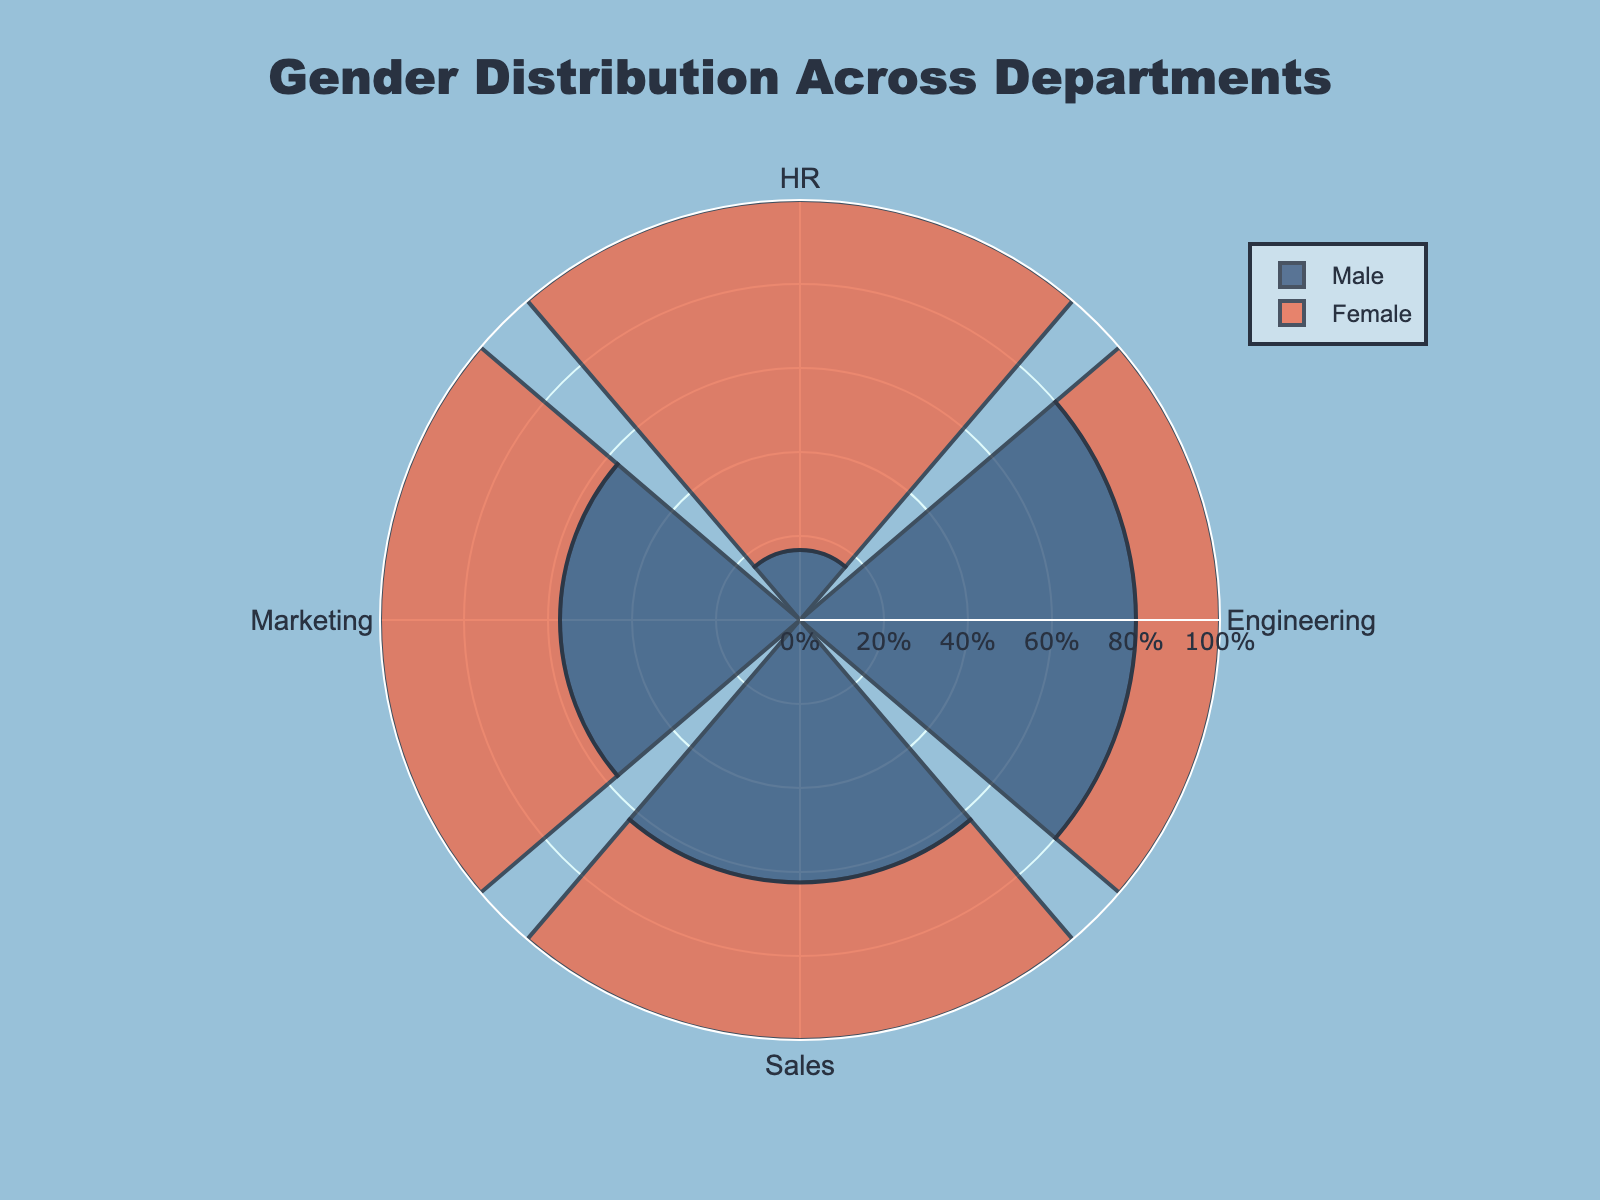What's the title of the figure? The title is usually positioned at the top of the figure in larger and bold text. In this case, the title specifies what the figure is about.
Answer: Gender Distribution Across Departments What are the represented departments in the plot? The departments are labeled around the circular axis. Each tick mark corresponds to a department.
Answer: Sales, Engineering, Marketing, HR Which department has the highest percentage of male employees? By examining the length of the bar for male employees in each department, we can determine the department with the highest percentage.
Answer: Engineering Which department has the highest percentage of female employees? By examining the length of the bar for female employees in each department, we can determine the department with the highest percentage.
Answer: HR What percentage of employees in the Sales department are female? For the Sales department, look at the length of the bar that represents females and check the percentage value associated with it.
Answer: 37.5% What is the percentage difference between male and female employees in Engineering? Find the percentage of male and female employees in Engineering and subtract the smaller percentage from the larger one. Engineering: Males 80%, Females 20%, so 80% - 20% = 60%.
Answer: 60% Compare the gender distribution in Marketing. Which gender is more prevalent and by how much? Identify the lengths of the bars representing males and females in Marketing, compare them, and find the difference. Marketing: Males 57.1%, Females 42.9%, difference is 57.1% - 42.9% = 14.2%.
Answer: Males by 14.2% What is the visual color used to represent male employees? Check the color coding of the bars associated with male employees.
Answer: Dark blue Which department has the most balanced gender distribution? The department with the smallest difference between the percentages of male and female employees is the most balanced.
Answer: Marketing Is there any department where females outnumber males, and if so, which one is it? Look for any department where the bar representing female employees is longer than the one for male employees.
Answer: HR 